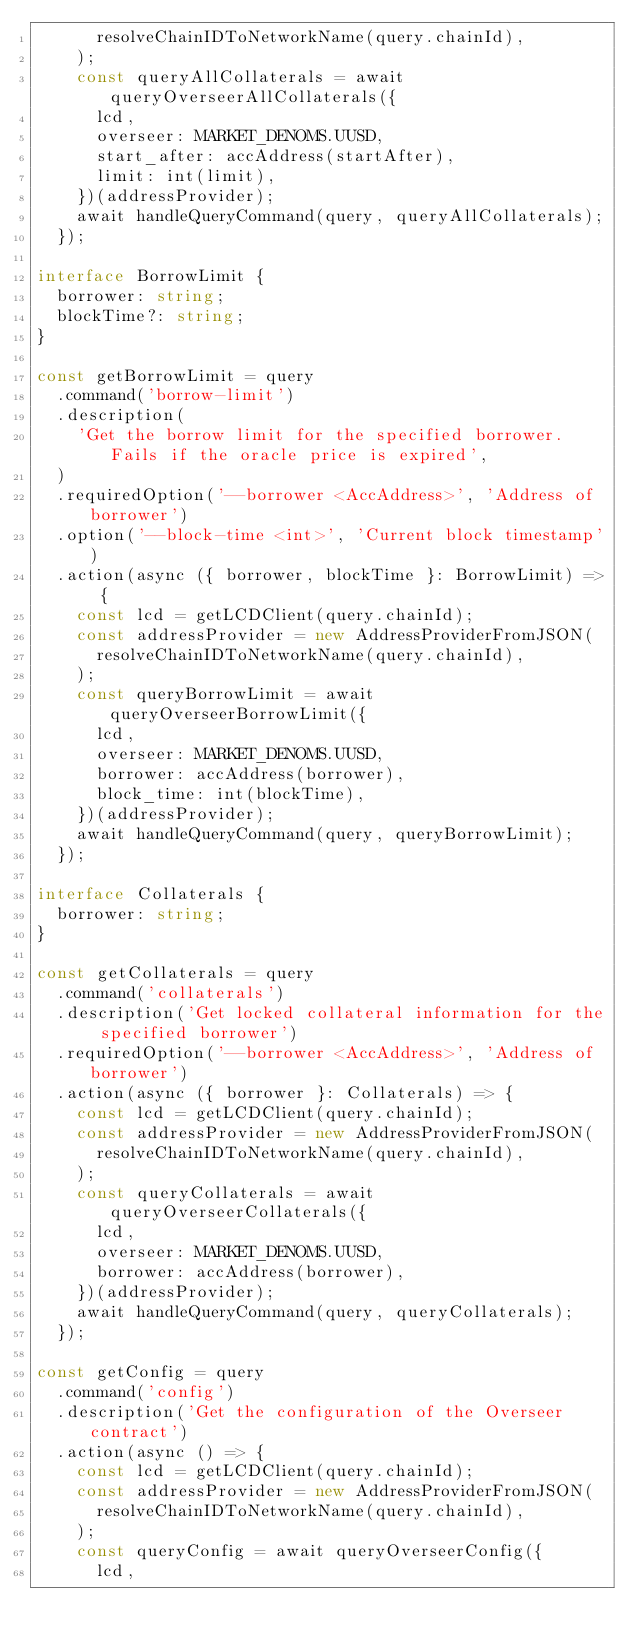Convert code to text. <code><loc_0><loc_0><loc_500><loc_500><_TypeScript_>      resolveChainIDToNetworkName(query.chainId),
    );
    const queryAllCollaterals = await queryOverseerAllCollaterals({
      lcd,
      overseer: MARKET_DENOMS.UUSD,
      start_after: accAddress(startAfter),
      limit: int(limit),
    })(addressProvider);
    await handleQueryCommand(query, queryAllCollaterals);
  });

interface BorrowLimit {
  borrower: string;
  blockTime?: string;
}

const getBorrowLimit = query
  .command('borrow-limit')
  .description(
    'Get the borrow limit for the specified borrower. Fails if the oracle price is expired',
  )
  .requiredOption('--borrower <AccAddress>', 'Address of borrower')
  .option('--block-time <int>', 'Current block timestamp')
  .action(async ({ borrower, blockTime }: BorrowLimit) => {
    const lcd = getLCDClient(query.chainId);
    const addressProvider = new AddressProviderFromJSON(
      resolveChainIDToNetworkName(query.chainId),
    );
    const queryBorrowLimit = await queryOverseerBorrowLimit({
      lcd,
      overseer: MARKET_DENOMS.UUSD,
      borrower: accAddress(borrower),
      block_time: int(blockTime),
    })(addressProvider);
    await handleQueryCommand(query, queryBorrowLimit);
  });

interface Collaterals {
  borrower: string;
}

const getCollaterals = query
  .command('collaterals')
  .description('Get locked collateral information for the specified borrower')
  .requiredOption('--borrower <AccAddress>', 'Address of borrower')
  .action(async ({ borrower }: Collaterals) => {
    const lcd = getLCDClient(query.chainId);
    const addressProvider = new AddressProviderFromJSON(
      resolveChainIDToNetworkName(query.chainId),
    );
    const queryCollaterals = await queryOverseerCollaterals({
      lcd,
      overseer: MARKET_DENOMS.UUSD,
      borrower: accAddress(borrower),
    })(addressProvider);
    await handleQueryCommand(query, queryCollaterals);
  });

const getConfig = query
  .command('config')
  .description('Get the configuration of the Overseer contract')
  .action(async () => {
    const lcd = getLCDClient(query.chainId);
    const addressProvider = new AddressProviderFromJSON(
      resolveChainIDToNetworkName(query.chainId),
    );
    const queryConfig = await queryOverseerConfig({
      lcd,</code> 